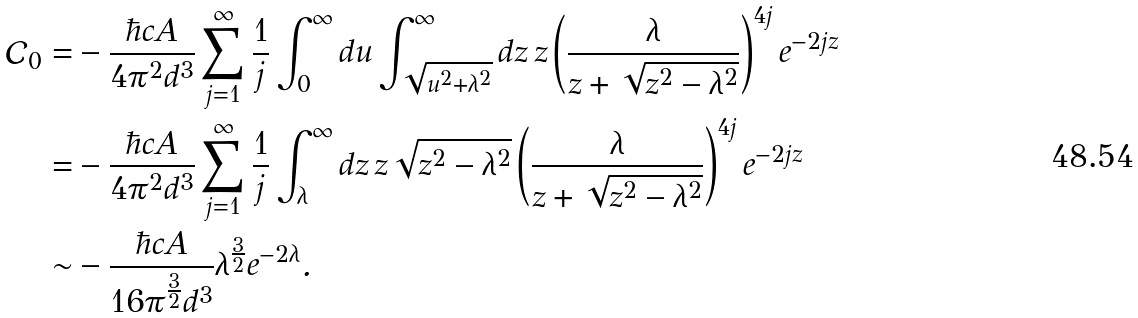Convert formula to latex. <formula><loc_0><loc_0><loc_500><loc_500>\mathcal { C } _ { 0 } = & - \frac { \hbar { c } A } { 4 \pi ^ { 2 } d ^ { 3 } } \sum _ { j = 1 } ^ { \infty } \frac { 1 } { j } \int _ { 0 } ^ { \infty } d u \int _ { \sqrt { u ^ { 2 } + \lambda ^ { 2 } } } ^ { \infty } d z \, z \left ( \frac { \lambda } { z + \sqrt { z ^ { 2 } - \lambda ^ { 2 } } } \right ) ^ { 4 j } e ^ { - 2 j z } \\ = & - \frac { \hbar { c } A } { 4 \pi ^ { 2 } d ^ { 3 } } \sum _ { j = 1 } ^ { \infty } \frac { 1 } { j } \int _ { \lambda } ^ { \infty } d z \, z \sqrt { z ^ { 2 } - \lambda ^ { 2 } } \left ( \frac { \lambda } { z + \sqrt { z ^ { 2 } - \lambda ^ { 2 } } } \right ) ^ { 4 j } e ^ { - 2 j z } \\ \sim & - \frac { \hbar { c } A } { 1 6 \pi ^ { \frac { 3 } { 2 } } d ^ { 3 } } \lambda ^ { \frac { 3 } { 2 } } e ^ { - 2 \lambda } .</formula> 